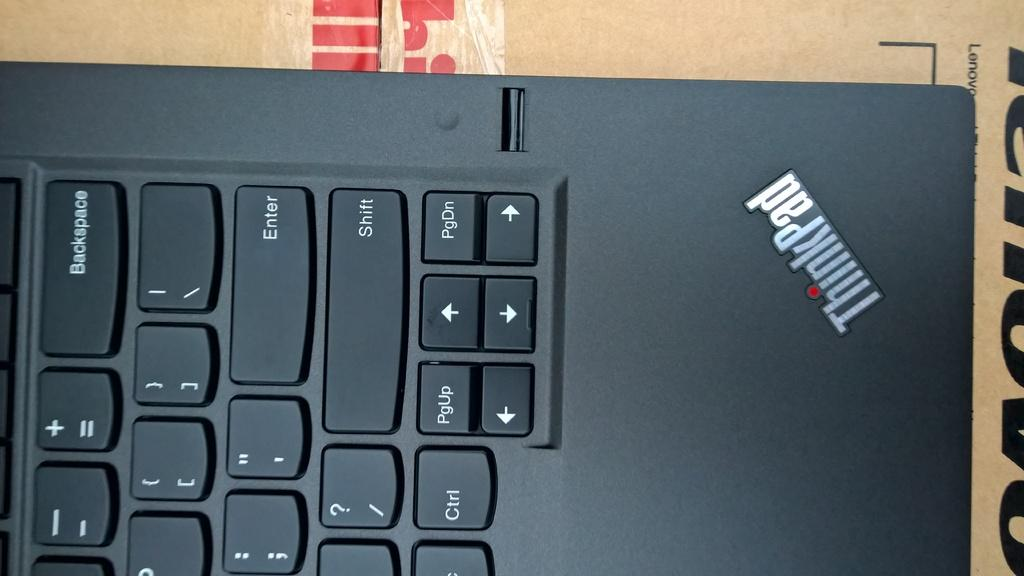<image>
Present a compact description of the photo's key features. A partial keyboard of a ThinkPad is shown with keys such as Enter and Shift visible. 